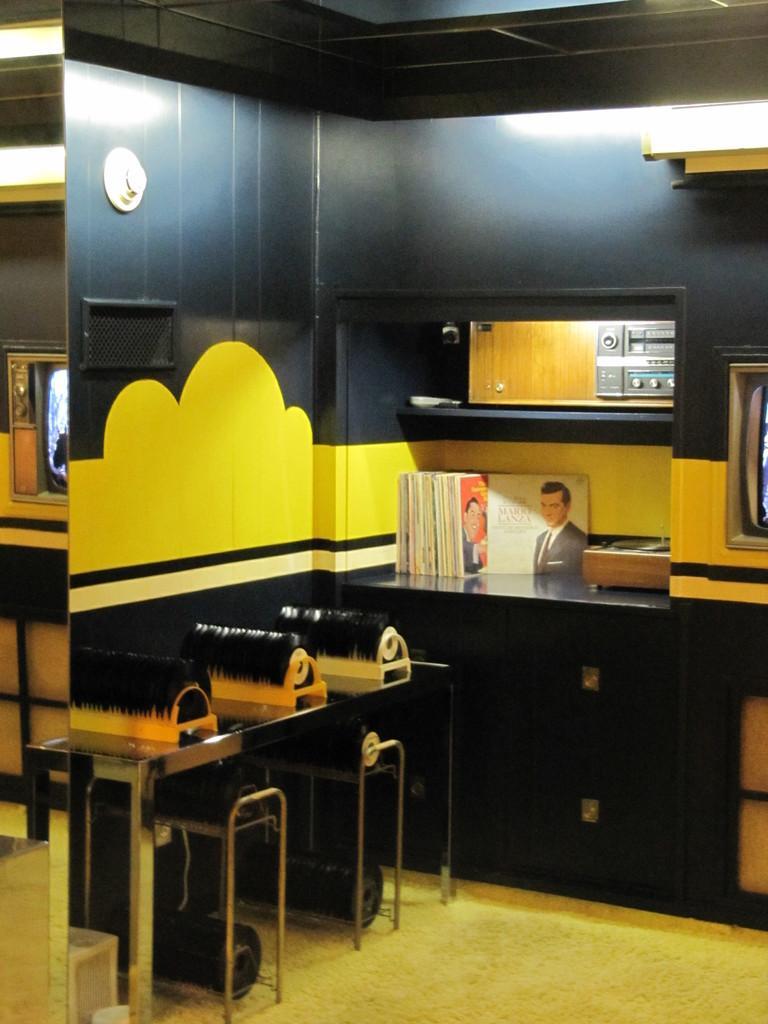Describe this image in one or two sentences. In this image I see a table on which there are few things and I see the wall which is of white, yellow and black in color and I see few books over here and I can also see the lights and I see the floor. 